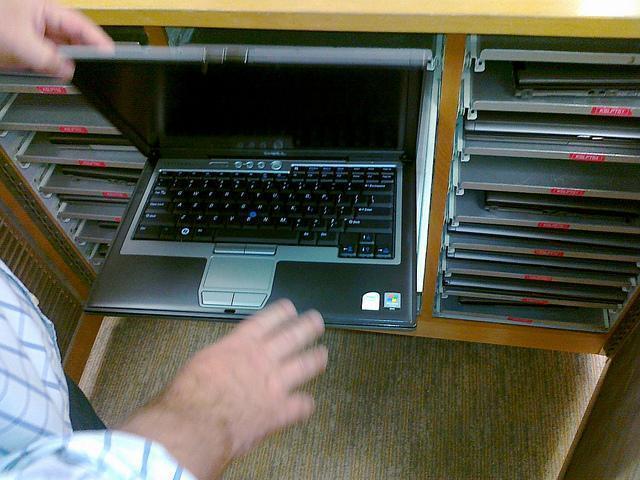How many laptops are there?
Give a very brief answer. 3. 